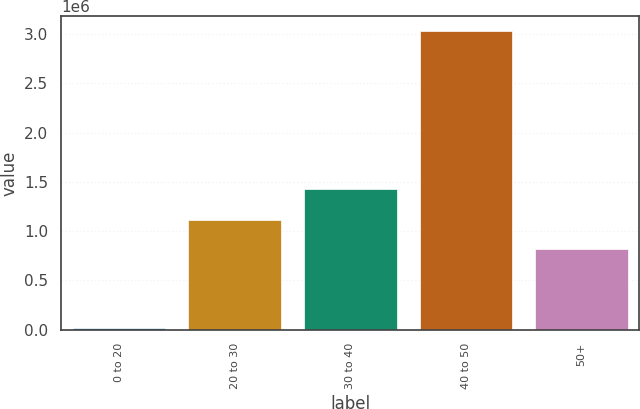Convert chart. <chart><loc_0><loc_0><loc_500><loc_500><bar_chart><fcel>0 to 20<fcel>20 to 30<fcel>30 to 40<fcel>40 to 50<fcel>50+<nl><fcel>12150<fcel>1.11716e+06<fcel>1.4229e+06<fcel>3.02875e+06<fcel>815500<nl></chart> 